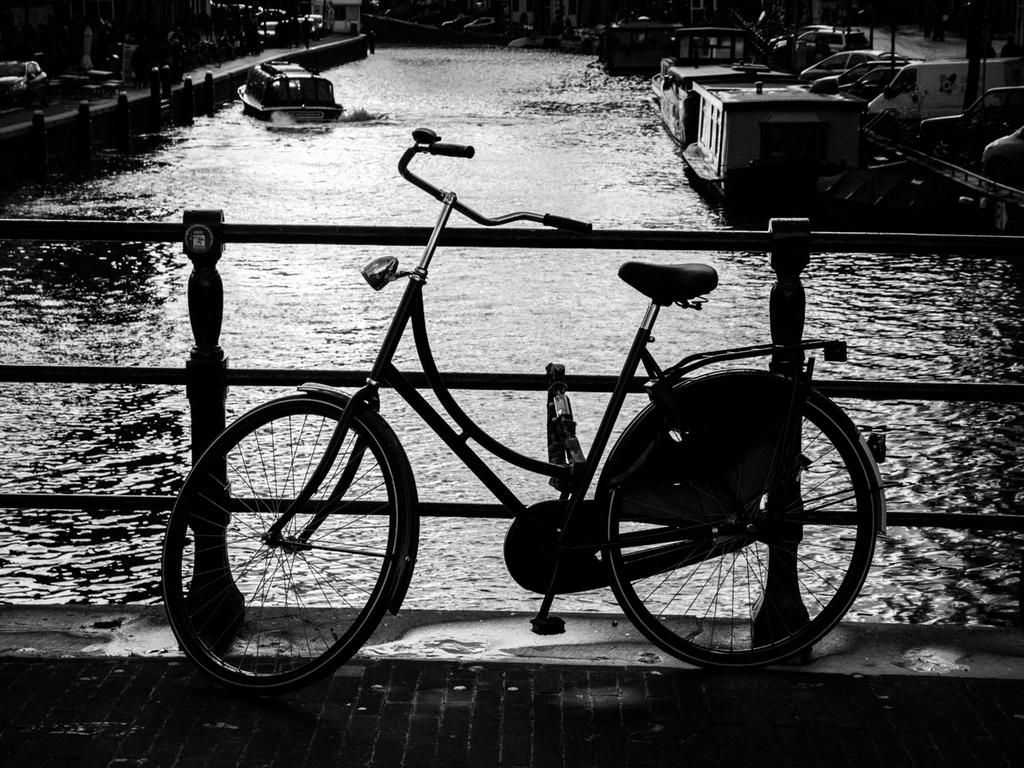What structure can be seen in the image? There is a bridge in the image. What feature does the bridge have? The bridge has railing. What mode of transportation is on the bridge? There is a bicycle on the bridge. What natural element is visible in the image? There is water visible in the image. What type of vehicles can be seen on the surface of the water? There are boats on the surface of the water. What type of vehicles can be seen on both sides of the water? There are vehicles on both sides of the water. What type of eggs can be seen floating in the water in the image? There are no eggs visible in the image; only boats can be seen on the surface of the water. 